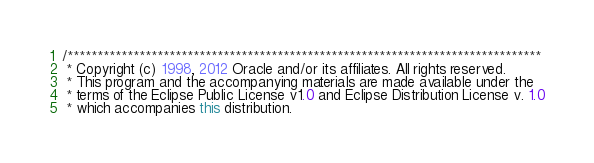<code> <loc_0><loc_0><loc_500><loc_500><_Java_>/*******************************************************************************
 * Copyright (c) 1998, 2012 Oracle and/or its affiliates. All rights reserved.
 * This program and the accompanying materials are made available under the
 * terms of the Eclipse Public License v1.0 and Eclipse Distribution License v. 1.0
 * which accompanies this distribution.</code> 